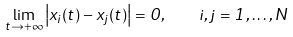<formula> <loc_0><loc_0><loc_500><loc_500>\lim _ { t \rightarrow + \infty } \left | x _ { i } ( t ) - x _ { j } ( t ) \right | = 0 , \quad i , j = 1 , \dots , N</formula> 